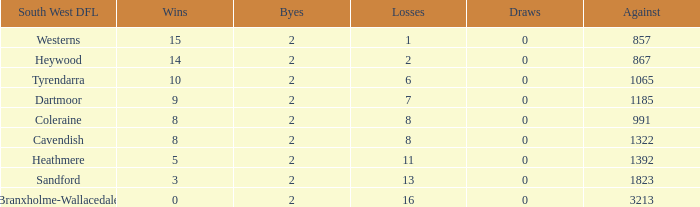How many wins have 16 losses and an Against smaller than 3213? None. 